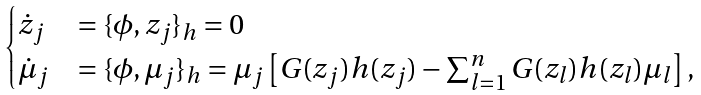<formula> <loc_0><loc_0><loc_500><loc_500>\begin{cases} \dot { z } _ { j } & = \{ \phi , z _ { j } \} _ { h } = 0 \\ \dot { \mu } _ { j } & = \{ \phi , \mu _ { j } \} _ { h } = \mu _ { j } \left [ G ( z _ { j } ) h ( z _ { j } ) - \sum _ { l = 1 } ^ { n } G ( z _ { l } ) h ( z _ { l } ) \mu _ { l } \right ] , \end{cases}</formula> 